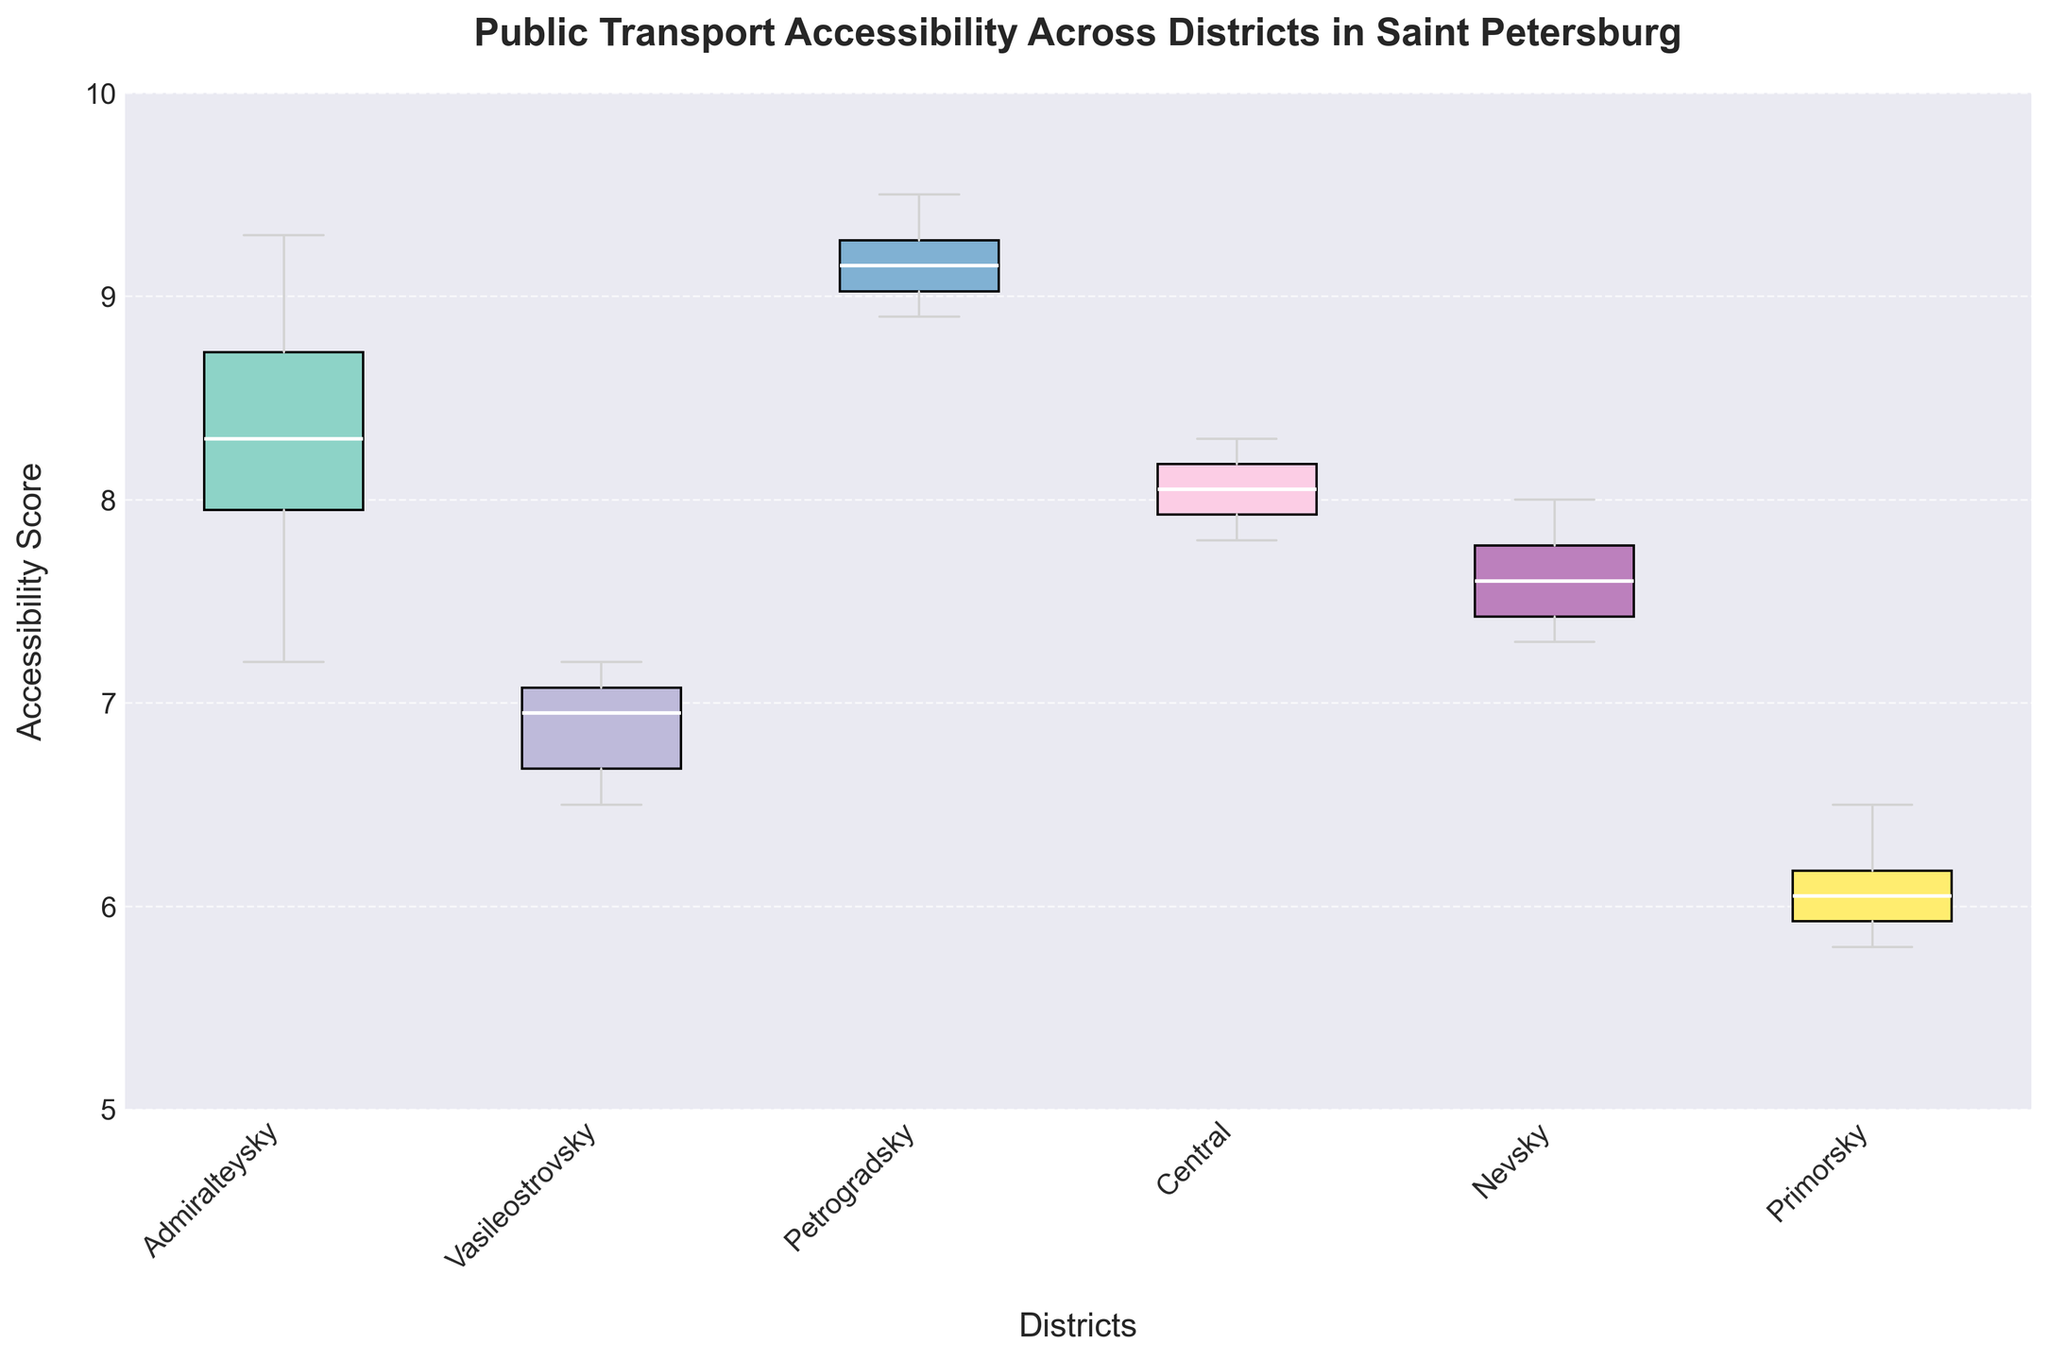What is the title of the figure? The title is usually positioned at the top of the figure and is easy to read. It conveys the main topic of the figure.
Answer: Public Transport Accessibility Across Districts in Saint Petersburg Which district has the highest median accessibility score? The median value for each district can be identified as the line inside each box in the box plot. The highest median line will indicate the district with the highest median accessibility score.
Answer: Petrogradsky How many districts are compared in the figure? The different colored boxes represent different districts. By counting the number of boxes, we find the number of districts.
Answer: 6 What is the range of the accessibility scores for the Primorsky district? The range is determined by the difference between the top whisker and the bottom whisker of the box plot for Primorsky.
Answer: 5.8 to 6.5 Which district shows the widest variability in accessibility scores? The variability is indicated by the length of the box and whiskers. The district with the largest distance from the top whisker to the bottom whisker shows the widest variability.
Answer: Admiralteysky What is the interquartile range (IQR) of accessibility scores for the Central district? The IQR is the difference between the third quartile (top of the box) and the first quartile (bottom of the box).
Answer: 8.2 - 7.9 Which districts have overlapping ranges of accessibility scores? By visually inspecting the whiskers of each district's box, we can see which districts' accessibility score ranges overlap.
Answer: Admiralteysky and Petrogradsky Are there any outliers in the data? If so, which districts have them? Outliers are typically indicated by individual points outside the whiskers in a box plot.
Answer: No outliers Which district has the lowest minimum accessibility score? The minimum score is indicated by the bottom whisker of each box plot. The district with the lowest bottom whisker has the lowest minimum accessibility score.
Answer: Primorsky What is the second highest median accessibility score, and which district does it belong to? First, determine the median scores for all districts by looking at the lines within the boxes. Then, identify the second highest.
Answer: Admiralteysky, 8.5 